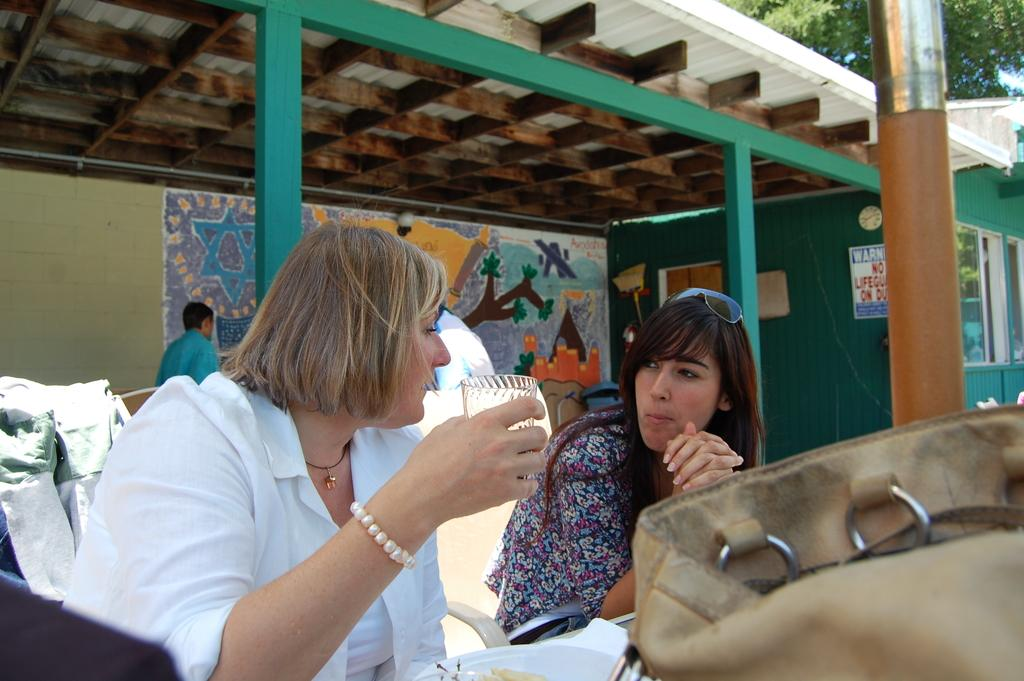How many people are in the image? There are people in the image, but the exact number is not specified. What object can be seen in the image that is commonly used for carrying items? There is a bag in the image. What protective eyewear is present in the image? There are goggles in the image. What material is transparent and visible in the image? There is glass in the image. What architectural feature is present in the image that provides shelter? There is a roof in the image. What type of printed material is present in the image? There is a poster in the image. What feature in the image allows light to enter and provides a view of the outside? There is a window in the image. What type of structure is present in the image that provides support? There are walls and pillars in the image. What unspecified objects are present in the image? There are some objects in the image. What type of vegetation can be seen in the background of the image? Leaves are visible in the background of the image. What type of pickle is being used to recite a verse in the image? There is no pickle or verse present in the image. What type of camera is being used to capture the scene in the image? The image does not show a camera being used to capture the scene; it is a static representation of the scene. 